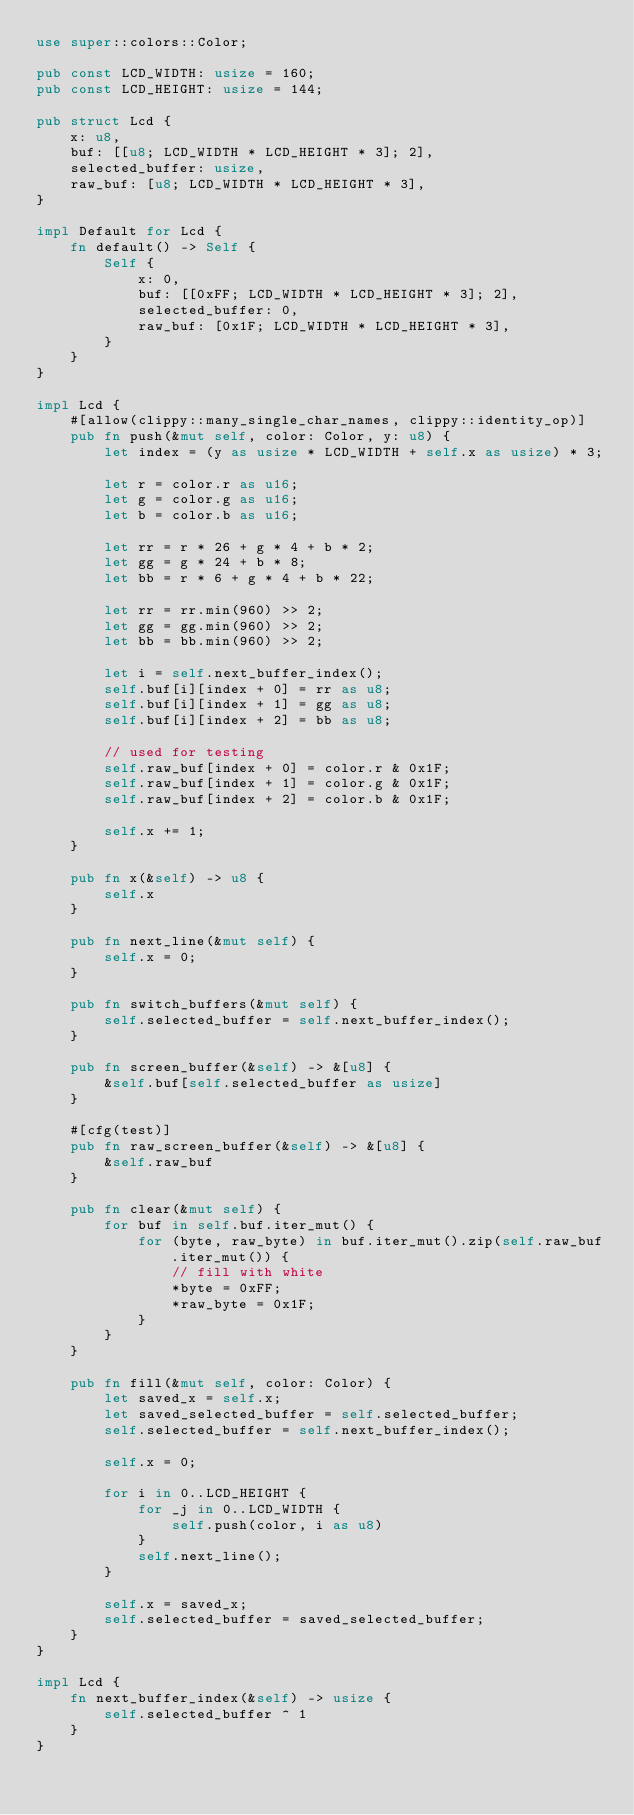<code> <loc_0><loc_0><loc_500><loc_500><_Rust_>use super::colors::Color;

pub const LCD_WIDTH: usize = 160;
pub const LCD_HEIGHT: usize = 144;

pub struct Lcd {
    x: u8,
    buf: [[u8; LCD_WIDTH * LCD_HEIGHT * 3]; 2],
    selected_buffer: usize,
    raw_buf: [u8; LCD_WIDTH * LCD_HEIGHT * 3],
}

impl Default for Lcd {
    fn default() -> Self {
        Self {
            x: 0,
            buf: [[0xFF; LCD_WIDTH * LCD_HEIGHT * 3]; 2],
            selected_buffer: 0,
            raw_buf: [0x1F; LCD_WIDTH * LCD_HEIGHT * 3],
        }
    }
}

impl Lcd {
    #[allow(clippy::many_single_char_names, clippy::identity_op)]
    pub fn push(&mut self, color: Color, y: u8) {
        let index = (y as usize * LCD_WIDTH + self.x as usize) * 3;

        let r = color.r as u16;
        let g = color.g as u16;
        let b = color.b as u16;

        let rr = r * 26 + g * 4 + b * 2;
        let gg = g * 24 + b * 8;
        let bb = r * 6 + g * 4 + b * 22;

        let rr = rr.min(960) >> 2;
        let gg = gg.min(960) >> 2;
        let bb = bb.min(960) >> 2;

        let i = self.next_buffer_index();
        self.buf[i][index + 0] = rr as u8;
        self.buf[i][index + 1] = gg as u8;
        self.buf[i][index + 2] = bb as u8;

        // used for testing
        self.raw_buf[index + 0] = color.r & 0x1F;
        self.raw_buf[index + 1] = color.g & 0x1F;
        self.raw_buf[index + 2] = color.b & 0x1F;

        self.x += 1;
    }

    pub fn x(&self) -> u8 {
        self.x
    }

    pub fn next_line(&mut self) {
        self.x = 0;
    }

    pub fn switch_buffers(&mut self) {
        self.selected_buffer = self.next_buffer_index();
    }

    pub fn screen_buffer(&self) -> &[u8] {
        &self.buf[self.selected_buffer as usize]
    }

    #[cfg(test)]
    pub fn raw_screen_buffer(&self) -> &[u8] {
        &self.raw_buf
    }

    pub fn clear(&mut self) {
        for buf in self.buf.iter_mut() {
            for (byte, raw_byte) in buf.iter_mut().zip(self.raw_buf.iter_mut()) {
                // fill with white
                *byte = 0xFF;
                *raw_byte = 0x1F;
            }
        }
    }

    pub fn fill(&mut self, color: Color) {
        let saved_x = self.x;
        let saved_selected_buffer = self.selected_buffer;
        self.selected_buffer = self.next_buffer_index();

        self.x = 0;

        for i in 0..LCD_HEIGHT {
            for _j in 0..LCD_WIDTH {
                self.push(color, i as u8)
            }
            self.next_line();
        }

        self.x = saved_x;
        self.selected_buffer = saved_selected_buffer;
    }
}

impl Lcd {
    fn next_buffer_index(&self) -> usize {
        self.selected_buffer ^ 1
    }
}
</code> 